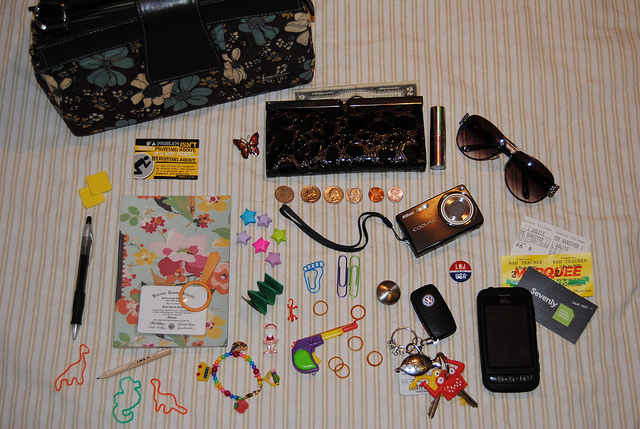How many kites in the sky? The image provided does not depict the sky or any kites. It seems to be a photograph of various items laid out on a surface, including a purse, sunglasses, a wallet, and other small personal items. There appears to be a misunderstanding as the question does not correspond to the content of the image. 